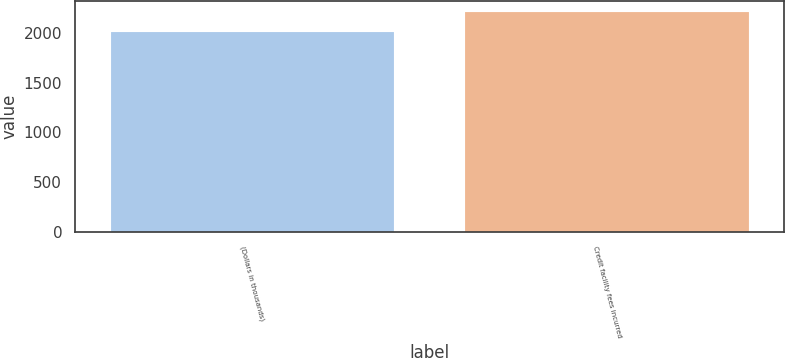<chart> <loc_0><loc_0><loc_500><loc_500><bar_chart><fcel>(Dollars in thousands)<fcel>Credit facility fees incurred<nl><fcel>2011<fcel>2211<nl></chart> 